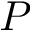<formula> <loc_0><loc_0><loc_500><loc_500>P</formula> 